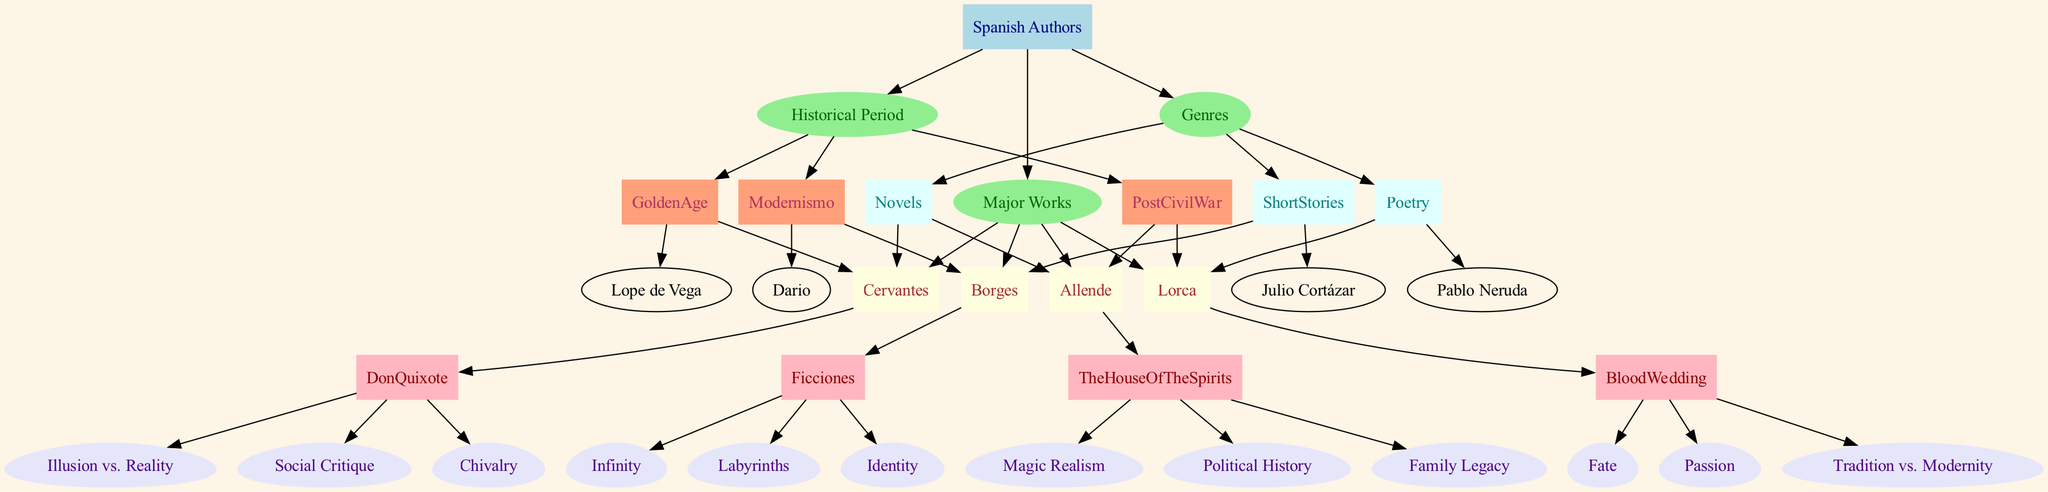What themes are associated with Cervantes' 'Don Quixote'? The diagram shows that 'Don Quixote' lists three themes: 'Illusion vs. Reality,' 'Social Critique,' and 'Chivalry' as specified in the connection from the work to its themes.
Answer: Illusion vs. Reality, Social Critique, Chivalry How many major works are there for Borges? By counting the individual work nodes under Borges in the 'Major Works' category, it's clear there is only one work displayed, which is 'Ficciones'.
Answer: 1 Which historical period includes the authors Lorca and Allende? The 'PostCivilWar' node connects to both authors, indicating that they belong to this historical period.
Answer: PostCivilWar What genre does 'Blood Wedding' belong to? Following the genre connection lines in the diagram, 'Blood Wedding' leads back to the genre 'Poetry,' which is connected to Lorca.
Answer: Poetry Who are the authors associated with the genre 'Short Stories'? The genre 'Short Stories' in the diagram is connected to two authors: Borges and Julio Cortázar, both explicitly mentioned as contributors to that genre.
Answer: Borges, Julio Cortázar What is the common theme explored in Borges' works? The diagram directly lists three themes associated with Borges' work 'Ficciones': 'Infinity,' 'Labyrinths,' and 'Identity,' indicating what can be seen as overarching themes in his literature.
Answer: Infinity, Labyrinths, Identity Which two authors are part of the Golden Age? By observing the 'GoldenAge' node, we see it connects to two authors, Cervantes and Lope de Vega, indicating their place in that historical period.
Answer: Cervantes, Lope de Vega How many authors are listed under the genre 'Novels'? Counting the connections under the 'Novels' genre, we find two authors listed: Allende and Cervantes.
Answer: 2 What themes does Allende’s 'The House of the Spirits' explore? The diagram notes the themes for 'The House of the Spirits,' which are 'Magic Realism,' 'Political History,' and 'Family Legacy'; this can be traced through the connections from the work to its listed themes.
Answer: Magic Realism, Political History, Family Legacy 